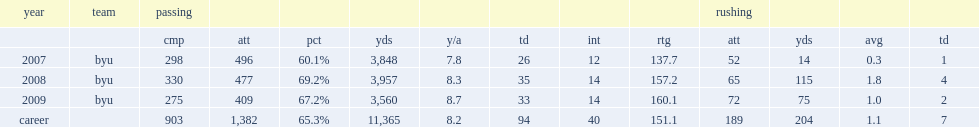What was a rating did max hall have in byu? 137.7. 